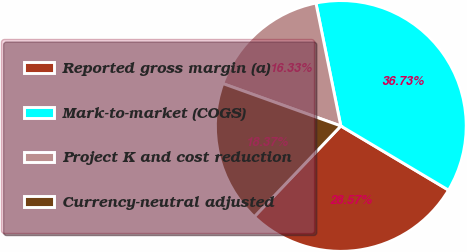Convert chart to OTSL. <chart><loc_0><loc_0><loc_500><loc_500><pie_chart><fcel>Reported gross margin (a)<fcel>Mark-to-market (COGS)<fcel>Project K and cost reduction<fcel>Currency-neutral adjusted<nl><fcel>28.57%<fcel>36.73%<fcel>16.33%<fcel>18.37%<nl></chart> 